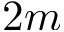<formula> <loc_0><loc_0><loc_500><loc_500>2 m</formula> 